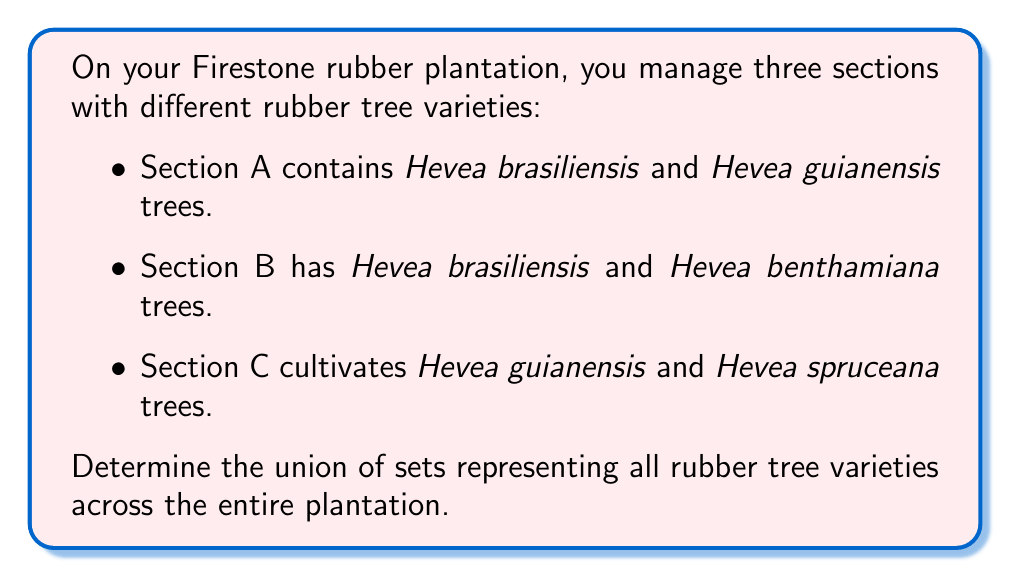Help me with this question. Let's approach this step-by-step using set theory:

1. Define the sets:
   Let A = {Hevea brasiliensis, Hevea guianensis}
   Let B = {Hevea brasiliensis, Hevea benthamiana}
   Let C = {Hevea guianensis, Hevea spruceana}

2. We need to find the union of these three sets, which is denoted as $A \cup B \cup C$.

3. The union of sets includes all unique elements from all sets without repetition.

4. Let's list all unique elements:
   - Hevea brasiliensis (from A and B)
   - Hevea guianensis (from A and C)
   - Hevea benthamiana (from B)
   - Hevea spruceana (from C)

5. The union can be written as:
   $A \cup B \cup C = \{$ Hevea brasiliensis, Hevea guianensis, Hevea benthamiana, Hevea spruceana $\}$

This set represents all unique rubber tree varieties across the entire plantation.
Answer: $A \cup B \cup C = \{$ Hevea brasiliensis, Hevea guianensis, Hevea benthamiana, Hevea spruceana $\}$ 